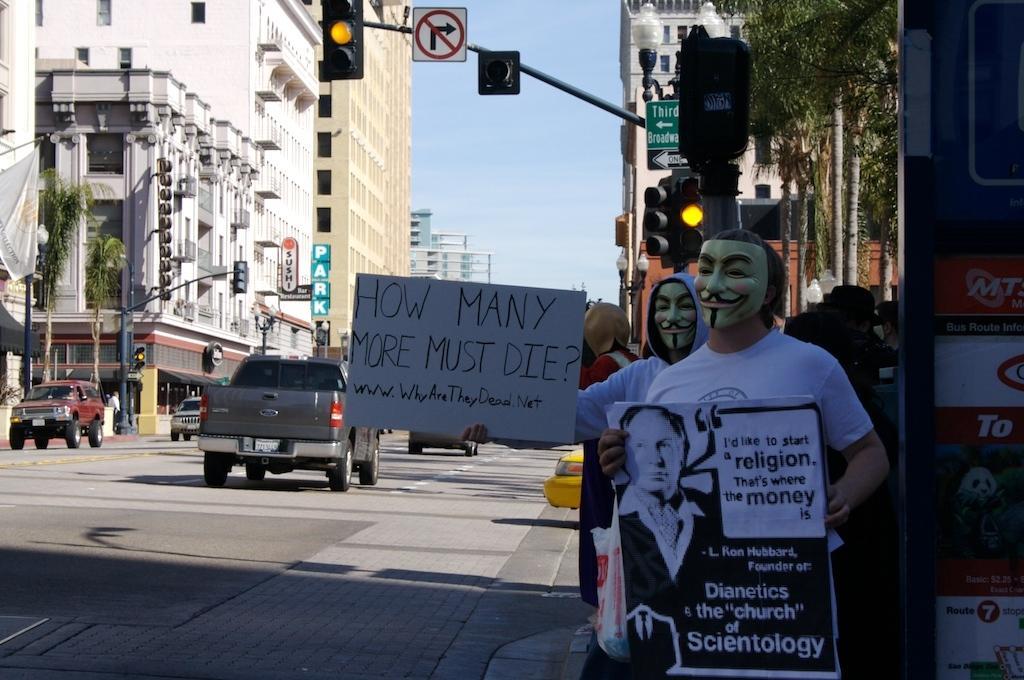Please provide a concise description of this image. In this picture there is a man wearing a white color t-shirt with joker mask holding a black and white poster in the hand. Behind there is a another man wearing a joker mask holding a board and standing on the roadside. On the road we can see two cars are moving. In the background there are some white building and signal pole. 